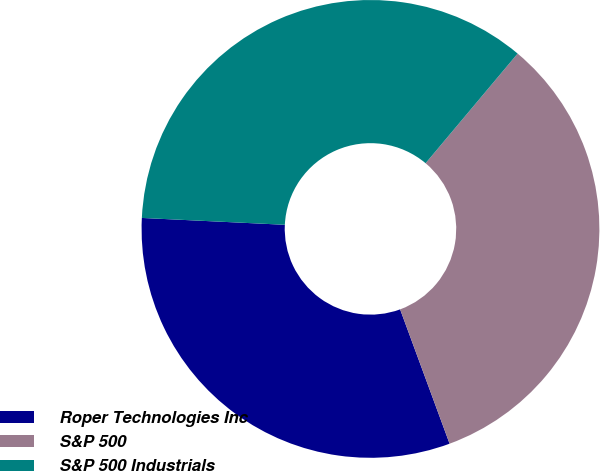Convert chart. <chart><loc_0><loc_0><loc_500><loc_500><pie_chart><fcel>Roper Technologies Inc<fcel>S&P 500<fcel>S&P 500 Industrials<nl><fcel>31.38%<fcel>33.27%<fcel>35.35%<nl></chart> 